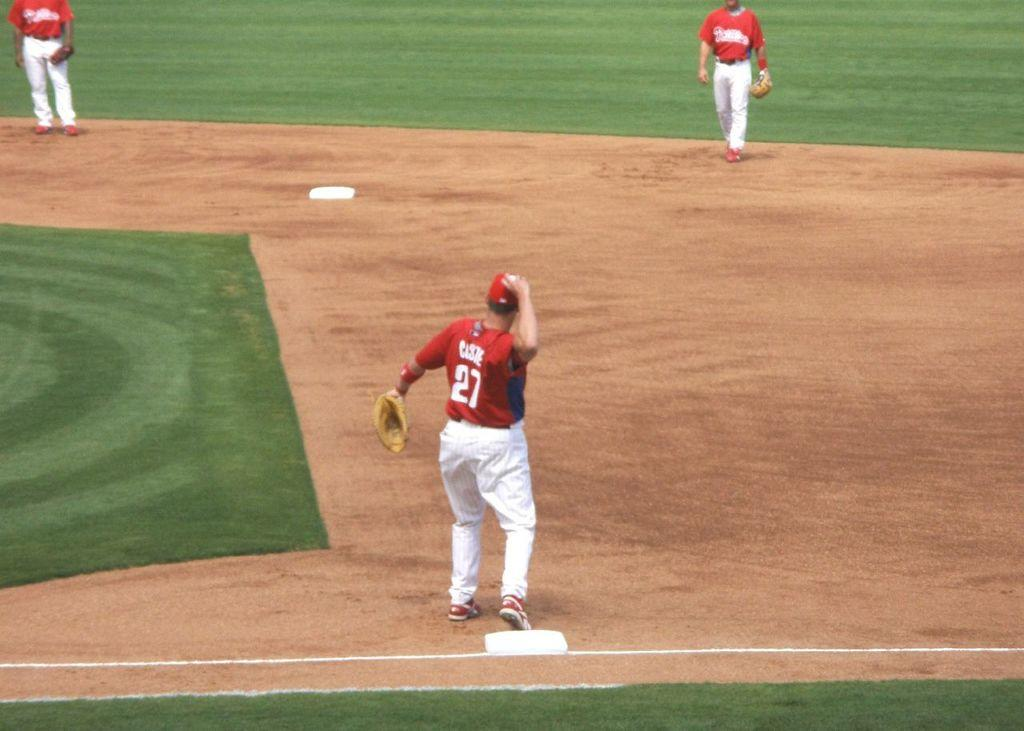<image>
Render a clear and concise summary of the photo. A man with number 27 on his jersey throwing a ball. 